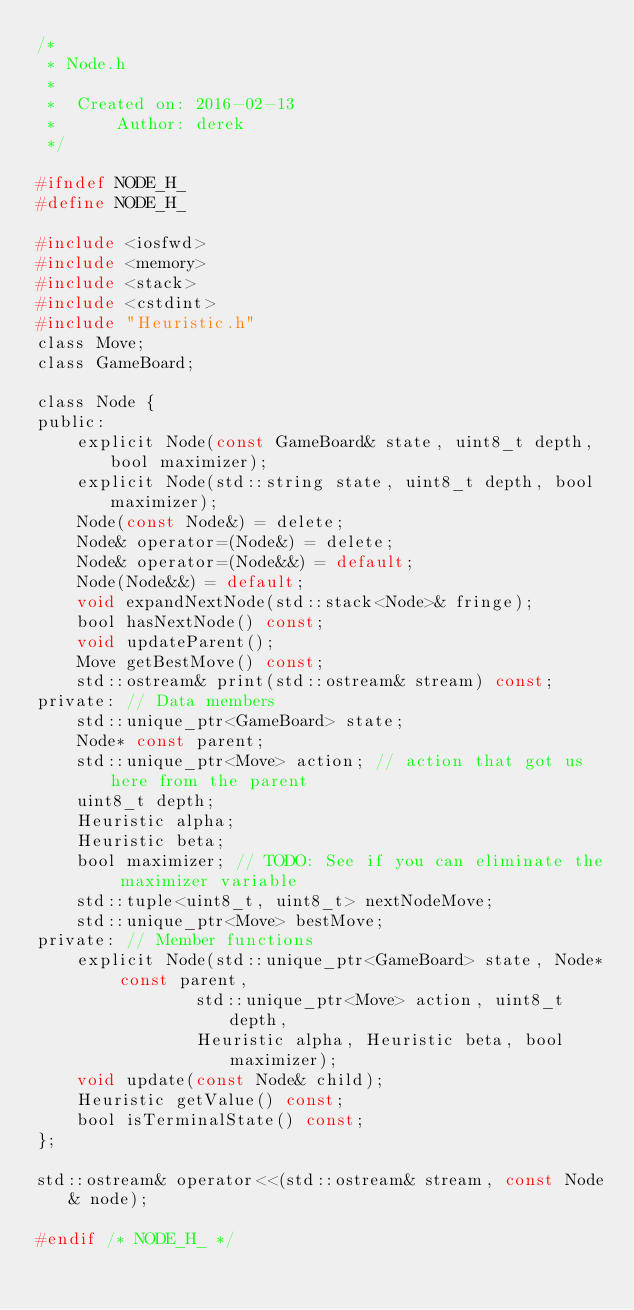Convert code to text. <code><loc_0><loc_0><loc_500><loc_500><_C_>/*
 * Node.h
 *
 *  Created on: 2016-02-13
 *      Author: derek
 */

#ifndef NODE_H_
#define NODE_H_

#include <iosfwd>
#include <memory>
#include <stack>
#include <cstdint>
#include "Heuristic.h"
class Move;
class GameBoard;

class Node {
public:
	explicit Node(const GameBoard& state, uint8_t depth, bool maximizer);
	explicit Node(std::string state, uint8_t depth, bool maximizer);
	Node(const Node&) = delete;
	Node& operator=(Node&) = delete;
	Node& operator=(Node&&) = default;
	Node(Node&&) = default;
	void expandNextNode(std::stack<Node>& fringe);
	bool hasNextNode() const;
	void updateParent();
	Move getBestMove() const;
	std::ostream& print(std::ostream& stream) const;
private: // Data members
	std::unique_ptr<GameBoard> state;
	Node* const parent;
	std::unique_ptr<Move> action; // action that got us here from the parent
	uint8_t depth;
	Heuristic alpha;
	Heuristic beta;
	bool maximizer; // TODO: See if you can eliminate the maximizer variable
	std::tuple<uint8_t, uint8_t> nextNodeMove;
	std::unique_ptr<Move> bestMove;
private: // Member functions
	explicit Node(std::unique_ptr<GameBoard> state, Node* const parent,
				std::unique_ptr<Move> action, uint8_t depth,
				Heuristic alpha, Heuristic beta, bool maximizer);
	void update(const Node& child);
	Heuristic getValue() const;
	bool isTerminalState() const;
};

std::ostream& operator<<(std::ostream& stream, const Node& node);

#endif /* NODE_H_ */
</code> 